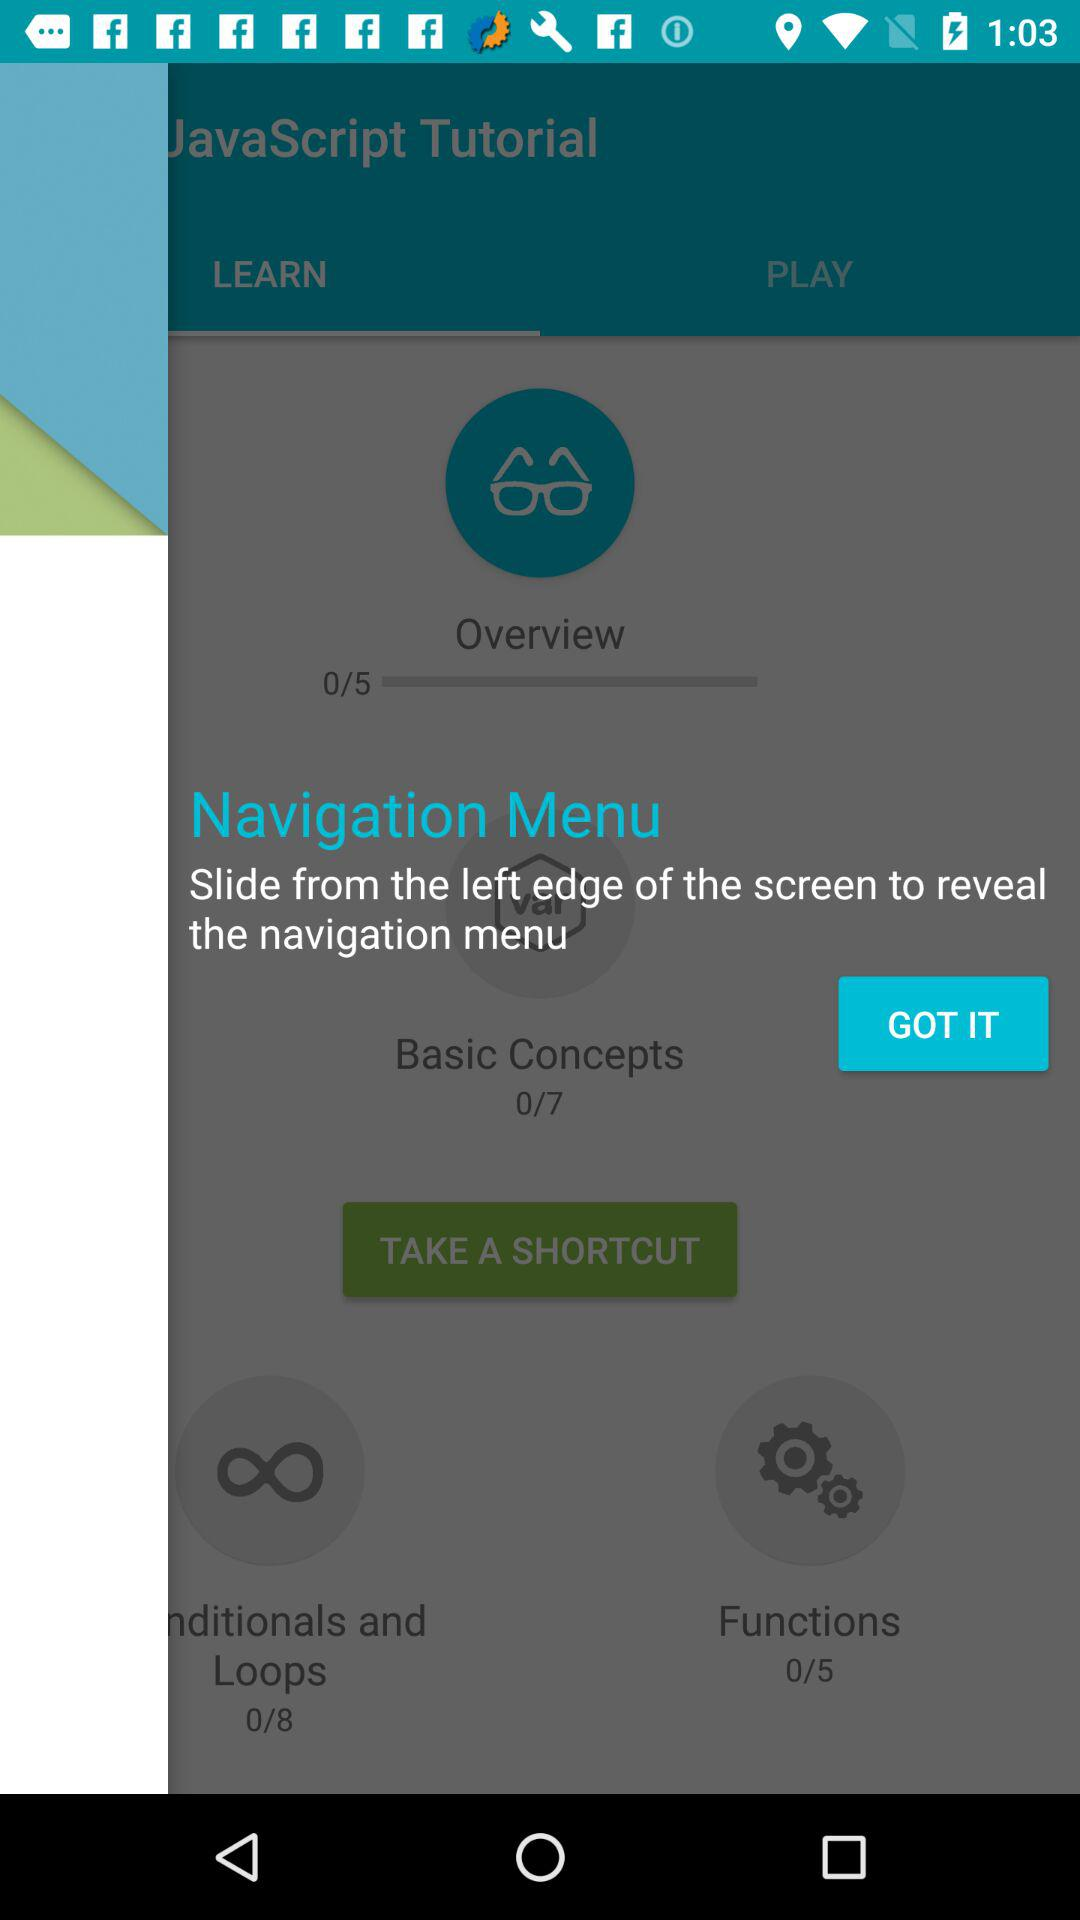What is the total number of overview? The total number of overview is 5. 